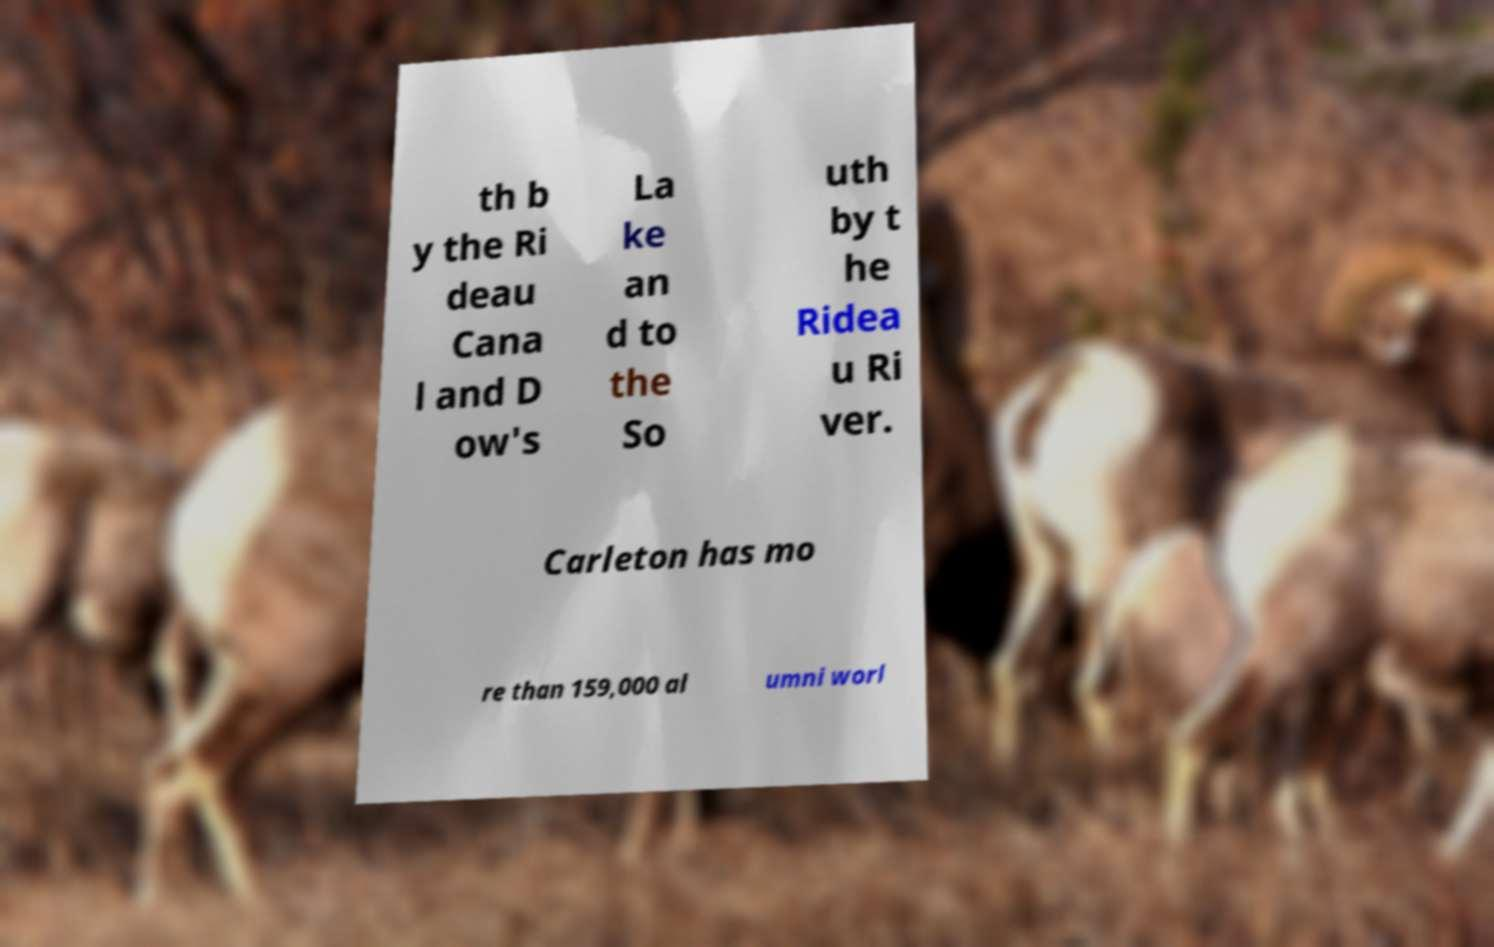Could you extract and type out the text from this image? th b y the Ri deau Cana l and D ow's La ke an d to the So uth by t he Ridea u Ri ver. Carleton has mo re than 159,000 al umni worl 